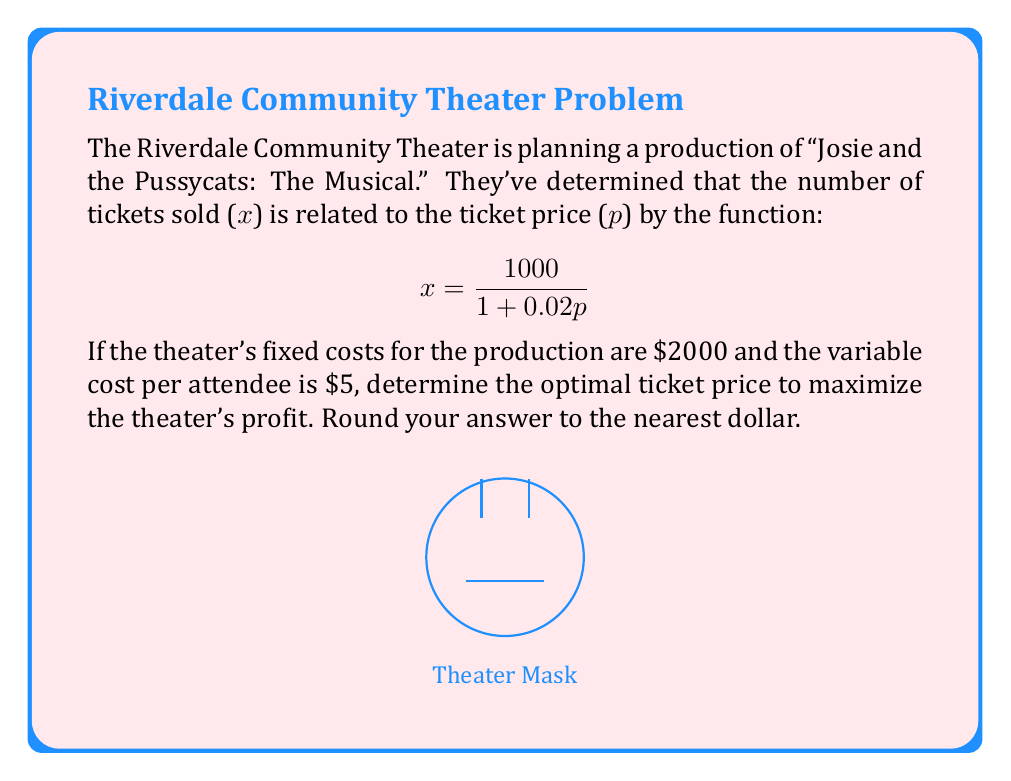Can you solve this math problem? Let's approach this step-by-step:

1) First, we need to create a profit function. Profit is revenue minus costs.
   
   Profit = Revenue - Fixed Costs - Variable Costs
   
   $$P = px - 2000 - 5x$$

2) Substitute the demand function for x:

   $$P = p(\frac{1000}{1 + 0.02p}) - 2000 - 5(\frac{1000}{1 + 0.02p})$$

3) Simplify:

   $$P = \frac{1000p}{1 + 0.02p} - 2000 - \frac{5000}{1 + 0.02p}$$

4) To find the maximum profit, we need to find where the derivative of P with respect to p equals zero:

   $$\frac{dP}{dp} = \frac{1000(1 + 0.02p) - 1000p(0.02)}{(1 + 0.02p)^2} + \frac{100}{(1 + 0.02p)^2} = 0$$

5) Simplify:

   $$\frac{1000 + 20000p - 20p}{(1 + 0.02p)^2} + \frac{100}{(1 + 0.02p)^2} = 0$$
   
   $$\frac{1100 + 19980p}{(1 + 0.02p)^2} = 0$$

6) The numerator must equal zero (the denominator can't be zero):

   $$1100 + 19980p = 0$$

7) Solve for p:

   $$19980p = -1100$$
   $$p = -\frac{1100}{19980} \approx 55.05$$

8) Round to the nearest dollar:

   p = $55
Answer: $55 